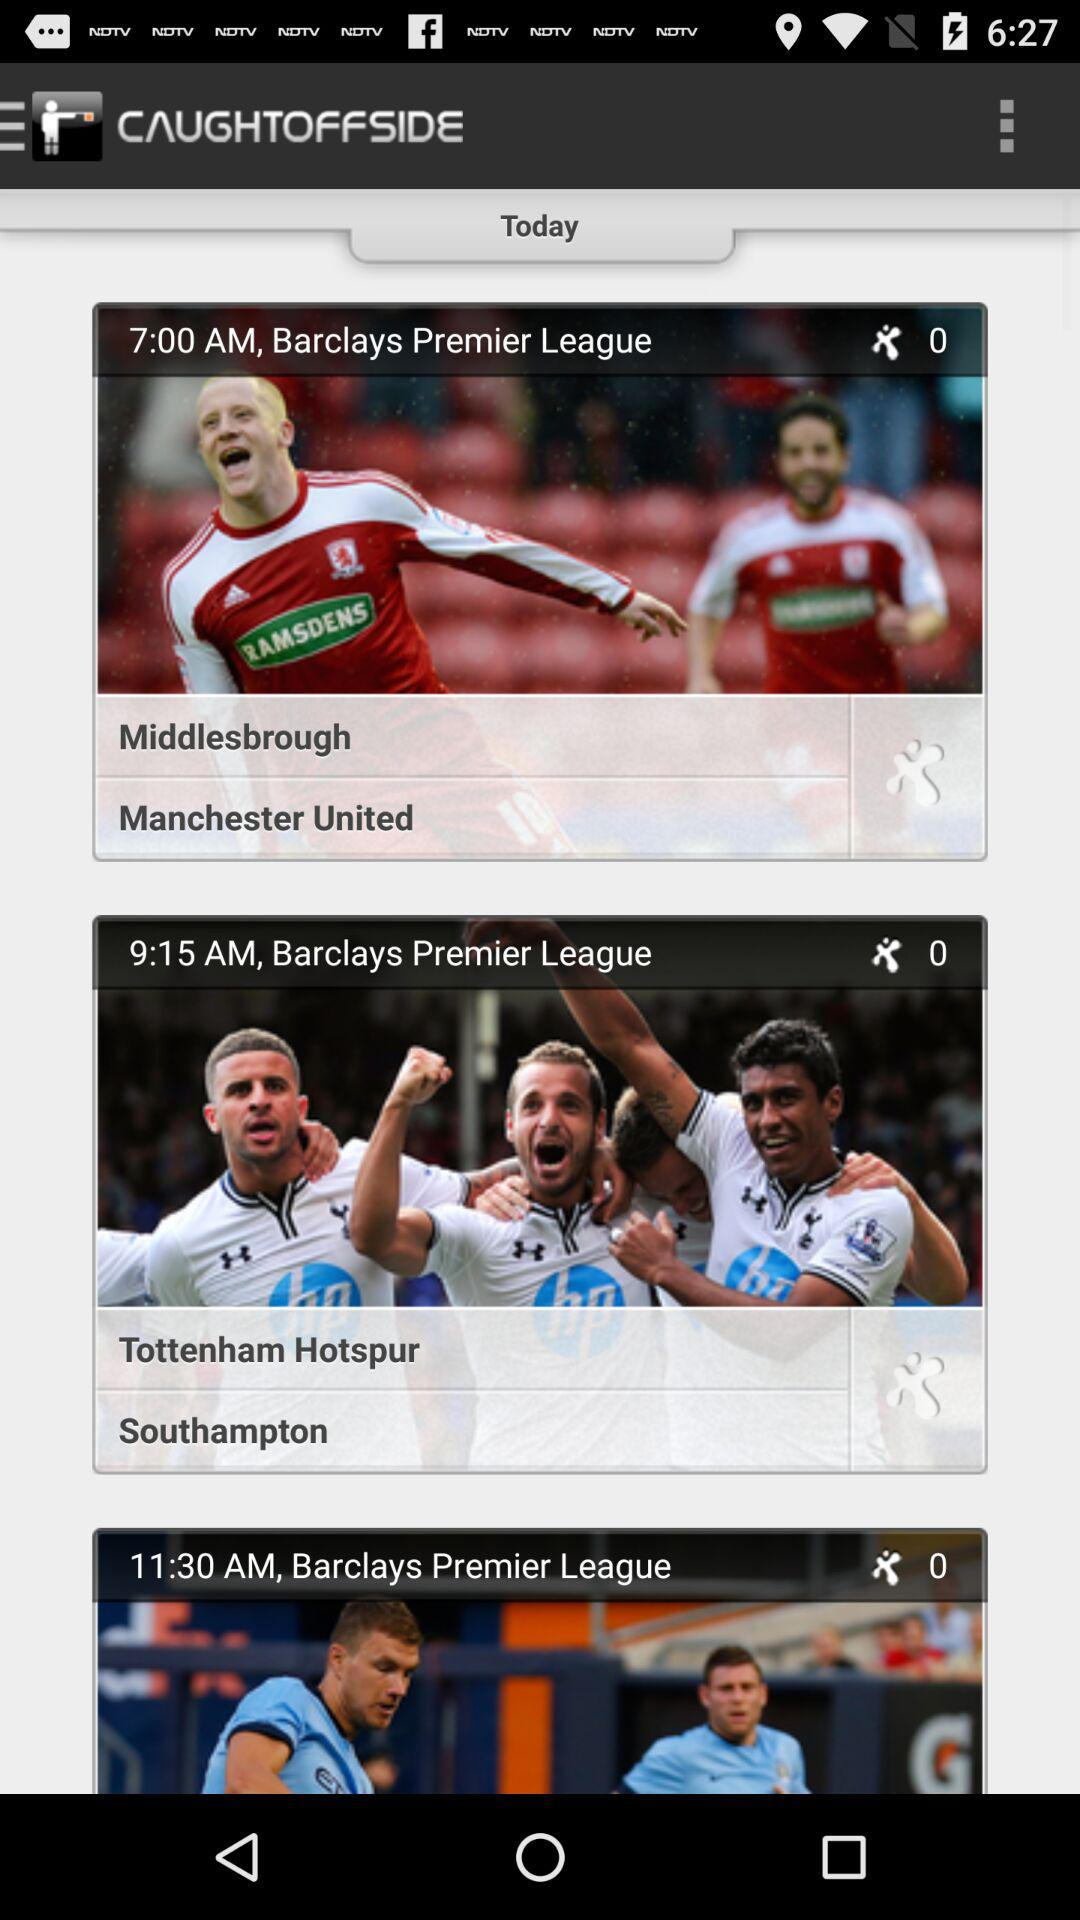At what time will the match between Middlesbrough and Manchester United start? The match will start at 7:00 AM. 